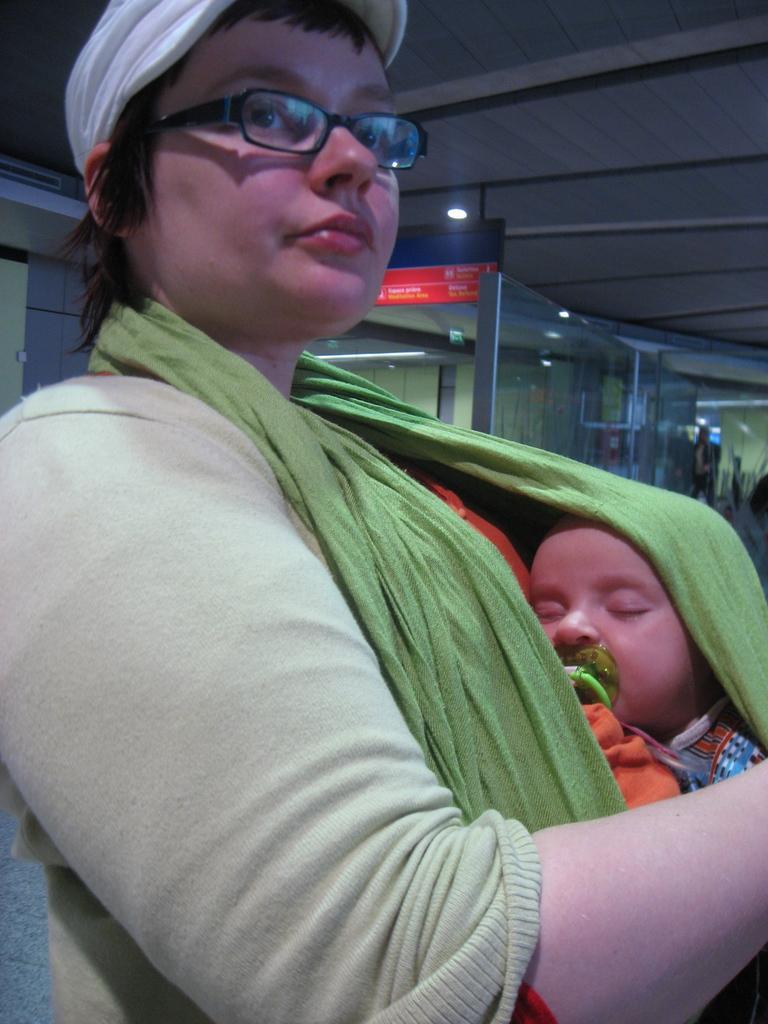Can you describe this image briefly? In this picture I can see there is a woman, she is sitting and wearing a green scarf, a sweater and spectacles and there is a baby and the baby is sleeping and in the backdrop there is a glass door and there is a board attached to the ceiling and there are few lights attached to the ceiling. 